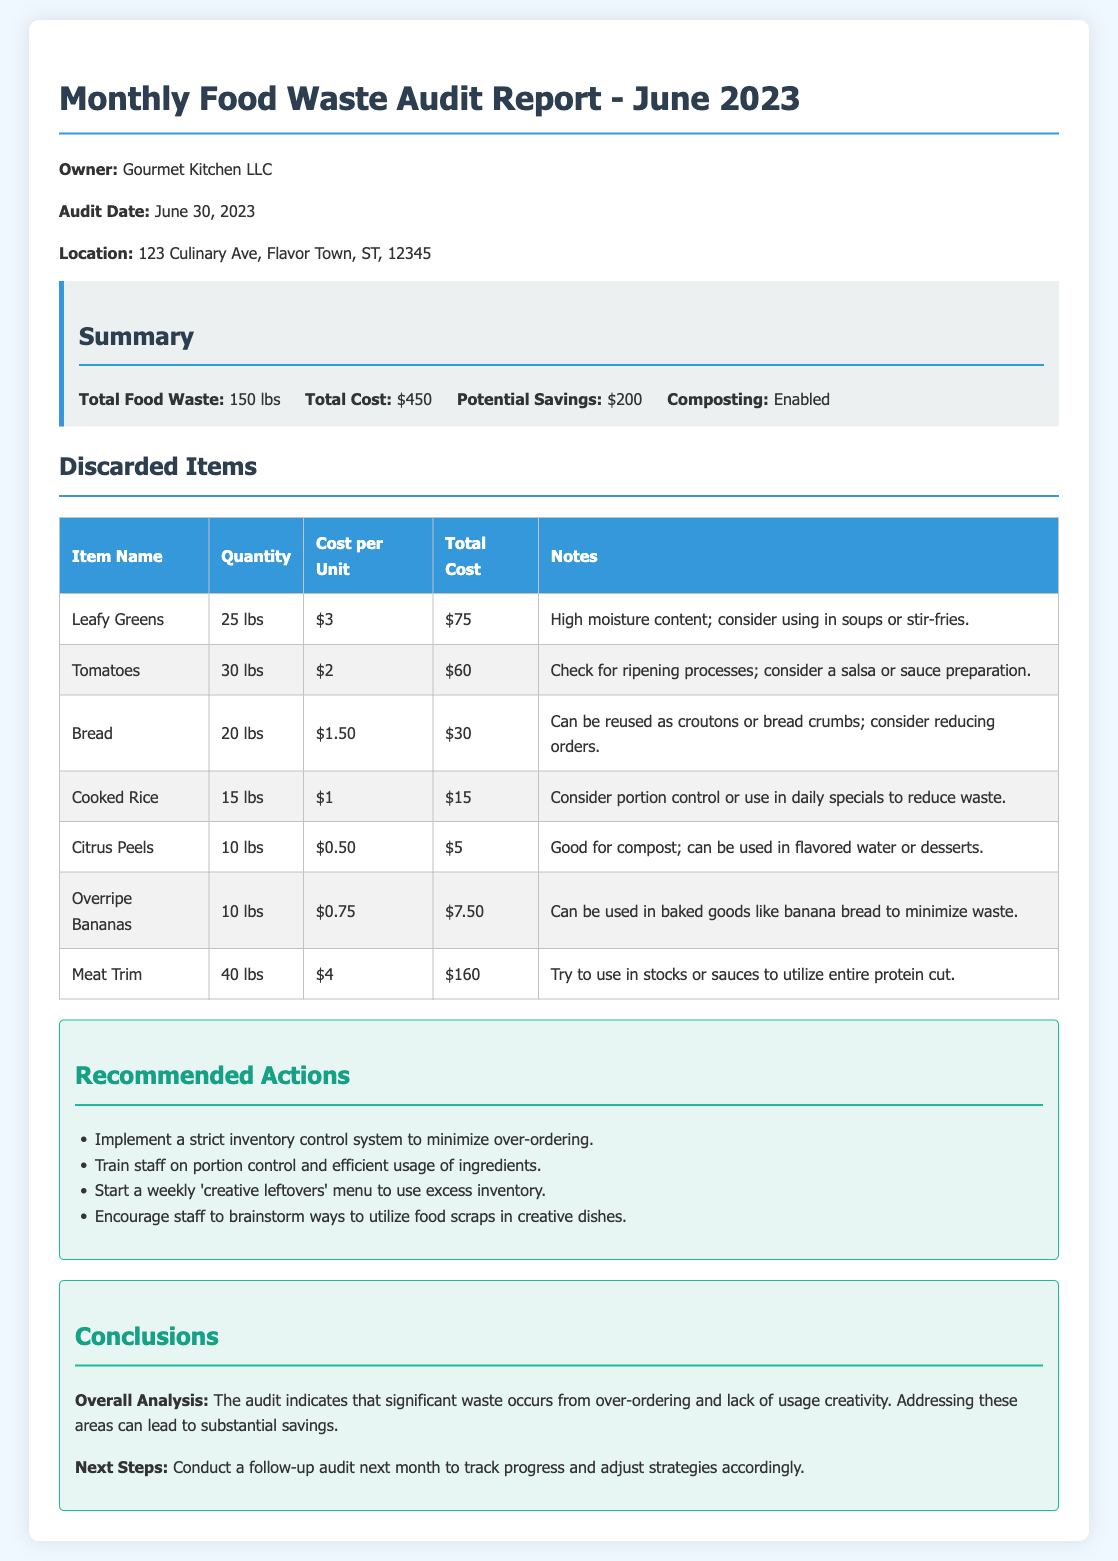What was the total food waste for June 2023? The total food waste is specified in the summary of the document as 150 lbs.
Answer: 150 lbs What is the total cost associated with the food waste? The total cost is mentioned in the summary section of the document as $450.
Answer: $450 What item had the highest total cost in the discard list? The item with the highest total cost is Meat Trim, which totals $160.
Answer: Meat Trim What potential savings are indicated in the report? The potential savings are highlighted in the summary as $200.
Answer: $200 What is one recommended action for reducing food waste? The document suggests implementing a strict inventory control system to minimize over-ordering as one recommended action.
Answer: Implement a strict inventory control system What specific date was the audit conducted? The date of the audit is recorded in the document as June 30, 2023.
Answer: June 30, 2023 How many pounds of overripe bananas were discarded? The quantity of overripe bananas discarded is listed as 10 lbs in the discarded items table.
Answer: 10 lbs What notes are provided for the discarded citrus peels? The notes indicate that citrus peels are good for compost and can be used in flavored water or desserts.
Answer: Good for compost; can be used in flavored water or desserts What does the audit's overall analysis suggest? The overall analysis suggests that significant waste occurs from over-ordering and lack of usage creativity.
Answer: Significant waste from over-ordering and lack of usage creativity 